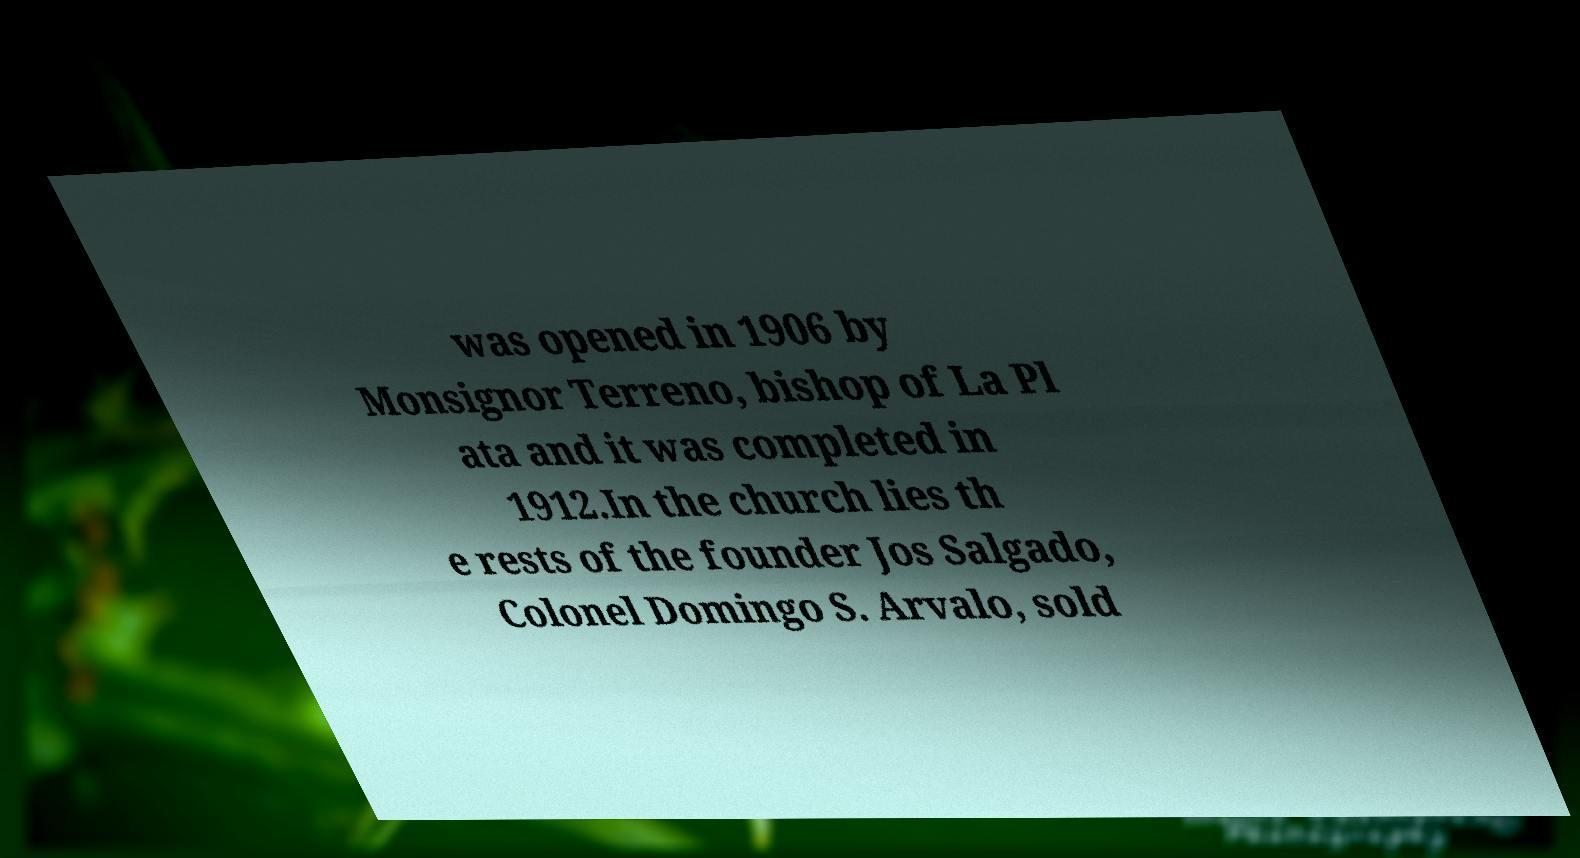For documentation purposes, I need the text within this image transcribed. Could you provide that? was opened in 1906 by Monsignor Terreno, bishop of La Pl ata and it was completed in 1912.In the church lies th e rests of the founder Jos Salgado, Colonel Domingo S. Arvalo, sold 